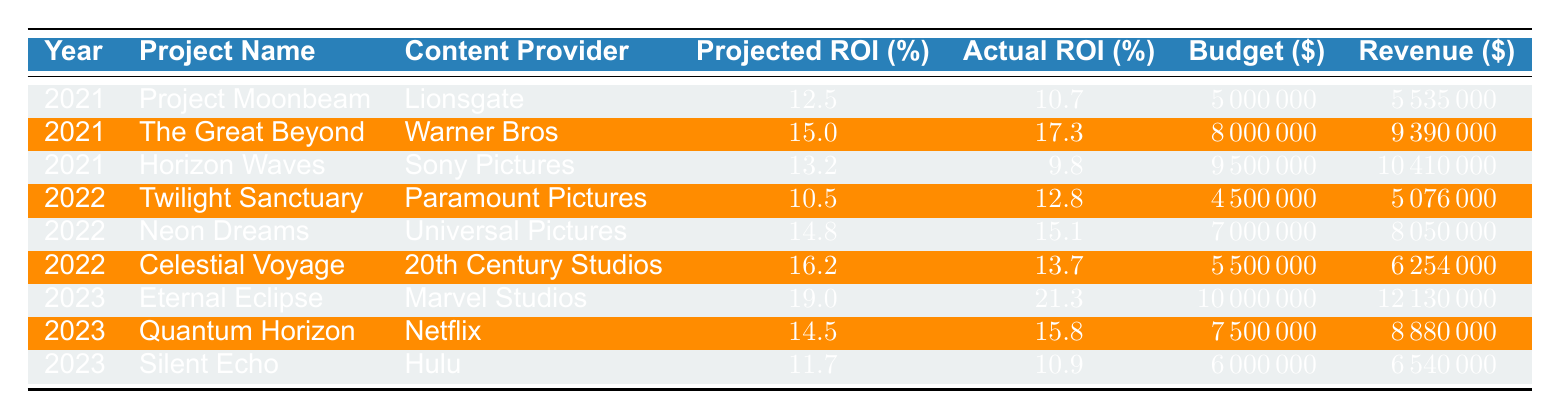What's the Actual ROI for "Quantum Horizon"? The table indicates that "Quantum Horizon" has an Actual ROI of 15.8%.
Answer: 15.8 In which year did "Twilight Sanctuary" achieve a higher Actual ROI than its Projected ROI? The table shows that in 2022, "Twilight Sanctuary" had a Projected ROI of 10.5% and an Actual ROI of 12.8%, which is higher than the projected value.
Answer: 2022 What is the total Budget for all projects in 2023? Adding the Budgets for the projects in 2023 gives: 10000000 + 7500000 + 6000000 = 24000000.
Answer: 24000000 Is the Actual ROI for "Horizon Waves" greater than its Projected ROI? The table indicates that "Horizon Waves" has a Projected ROI of 13.2% and an Actual ROI of 9.8%. Therefore, its Actual ROI is not greater than its Projected ROI.
Answer: No What is the average Projected ROI for all the projects from 2021 to 2023? The Projected ROIs are: 12.5, 15.0, 13.2, 10.5, 14.8, 16.2, 19.0, 14.5, and 11.7. The total sum is 127.9 and there are 9 projects, so the average is 127.9 / 9 = 14.21.
Answer: 14.21 Which project had the highest Actual ROI among all years? The highest Actual ROI in the table is 21.3% from "Eternal Eclipse" in 2023.
Answer: "Eternal Eclipse" Did any project in 2021 exceed its Projected ROI? From the 2021 projects, "The Great Beyond" had a Projected ROI of 15.0% and an Actual ROI of 17.3%, which exceeds the projected value.
Answer: Yes What is the difference between the budget for 2022 and 2021 combined? The total Budget for 2021 is 5000000 + 8000000 + 9500000 = 22500000 and for 2022 it is 4500000 + 7000000 + 5500000 = 17500000. The difference is 22500000 - 17500000 = 5000000.
Answer: 5000000 Which Content Provider had the lowest Actual ROI in 2021? Among the 2021 projects, "Horizon Waves" from Sony Pictures had the lowest Actual ROI of 9.8%.
Answer: Sony Pictures 